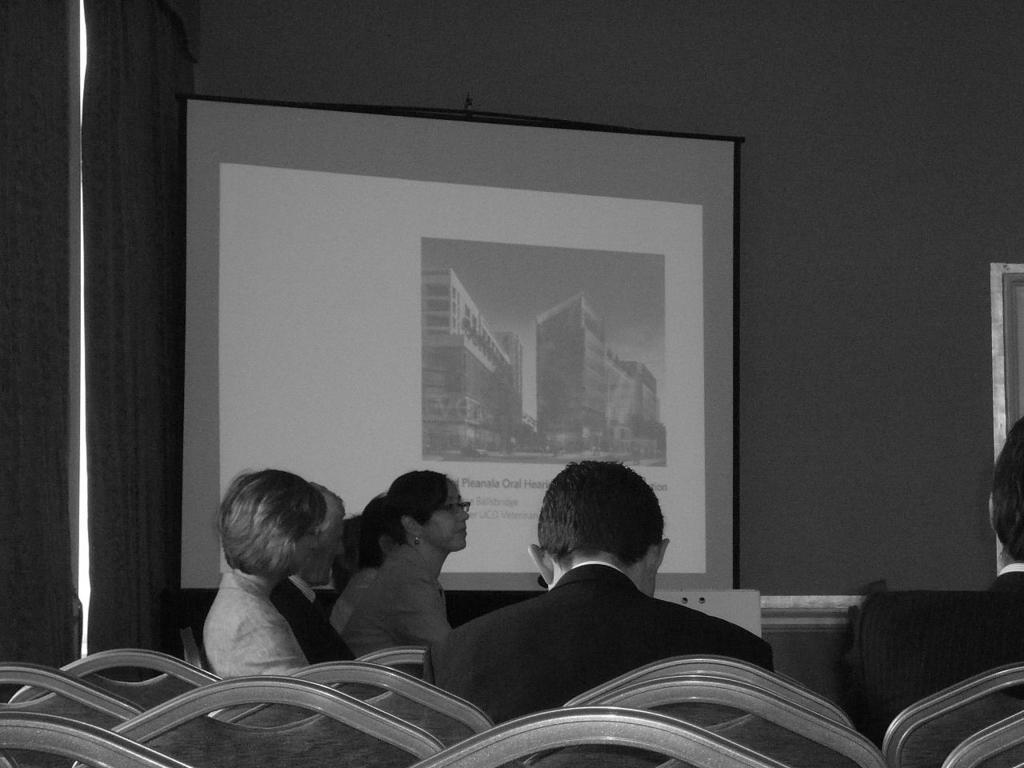Could you give a brief overview of what you see in this image? This is a black and white picture. In the foreground of the picture there are chairs and people. In the background there are curtain, projector screen and wall. 